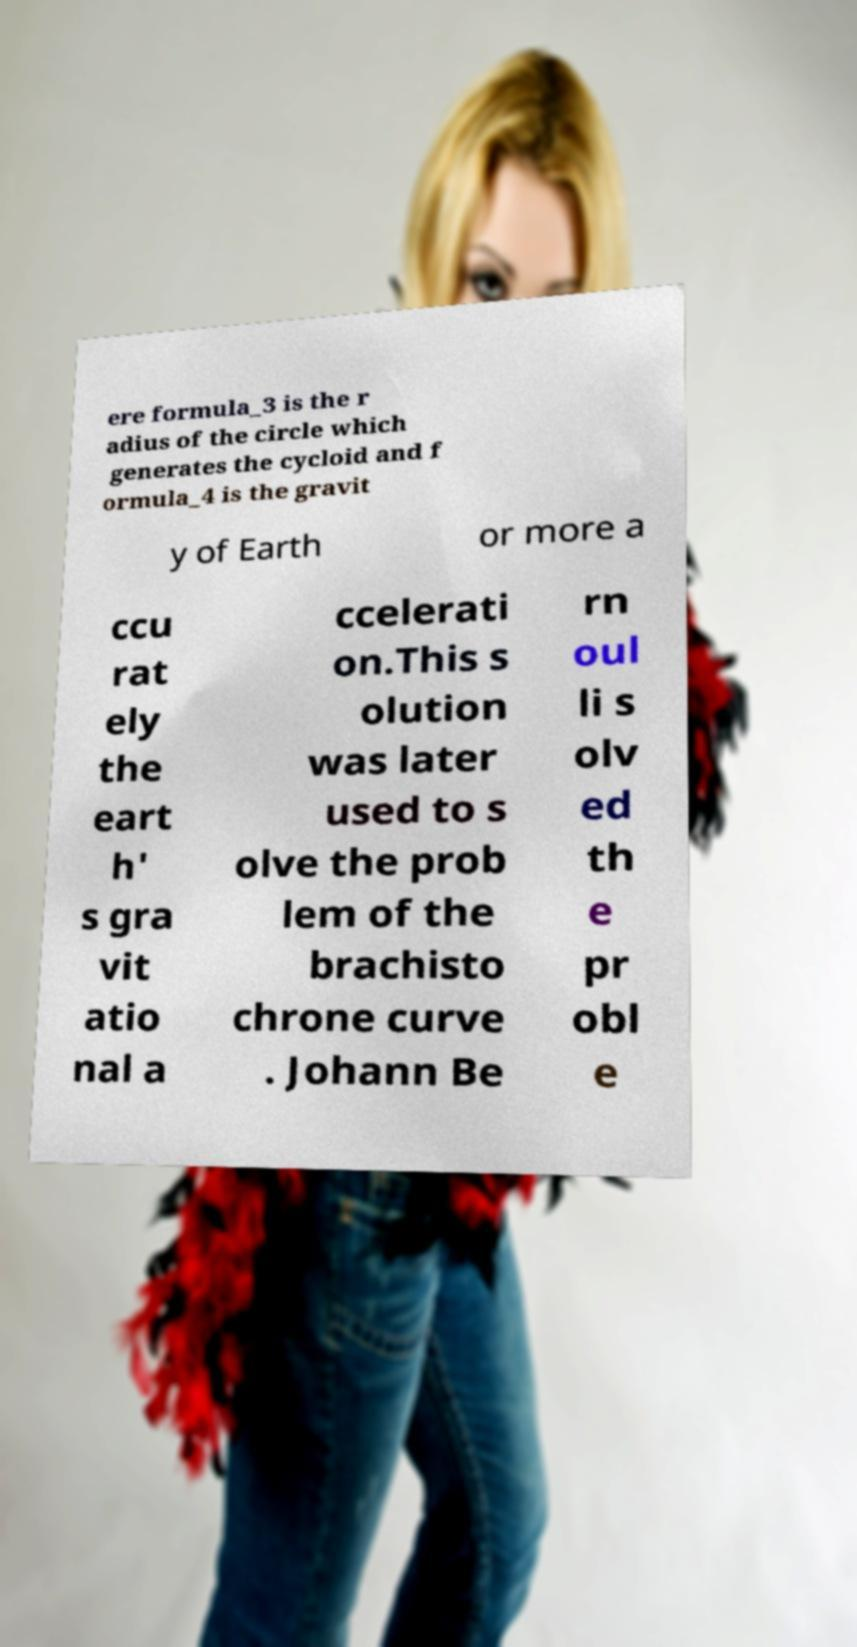I need the written content from this picture converted into text. Can you do that? ere formula_3 is the r adius of the circle which generates the cycloid and f ormula_4 is the gravit y of Earth or more a ccu rat ely the eart h' s gra vit atio nal a ccelerati on.This s olution was later used to s olve the prob lem of the brachisto chrone curve . Johann Be rn oul li s olv ed th e pr obl e 